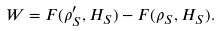Convert formula to latex. <formula><loc_0><loc_0><loc_500><loc_500>W = F ( \rho _ { S } ^ { \prime } , H _ { S } ) - F ( \rho _ { S } , H _ { S } ) .</formula> 